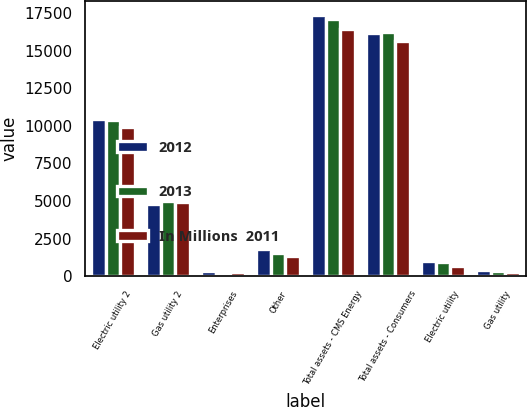<chart> <loc_0><loc_0><loc_500><loc_500><stacked_bar_chart><ecel><fcel>Electric utility 2<fcel>Gas utility 2<fcel>Enterprises<fcel>Other<fcel>Total assets - CMS Energy<fcel>Total assets - Consumers<fcel>Electric utility<fcel>Gas utility<nl><fcel>2012<fcel>10487<fcel>4784<fcel>332<fcel>1813<fcel>17416<fcel>16179<fcel>996<fcel>407<nl><fcel>2013<fcel>10423<fcel>5016<fcel>181<fcel>1511<fcel>17131<fcel>16275<fcel>921<fcel>340<nl><fcel>In Millions  2011<fcel>9938<fcel>4956<fcel>242<fcel>1316<fcel>16452<fcel>15662<fcel>661<fcel>261<nl></chart> 